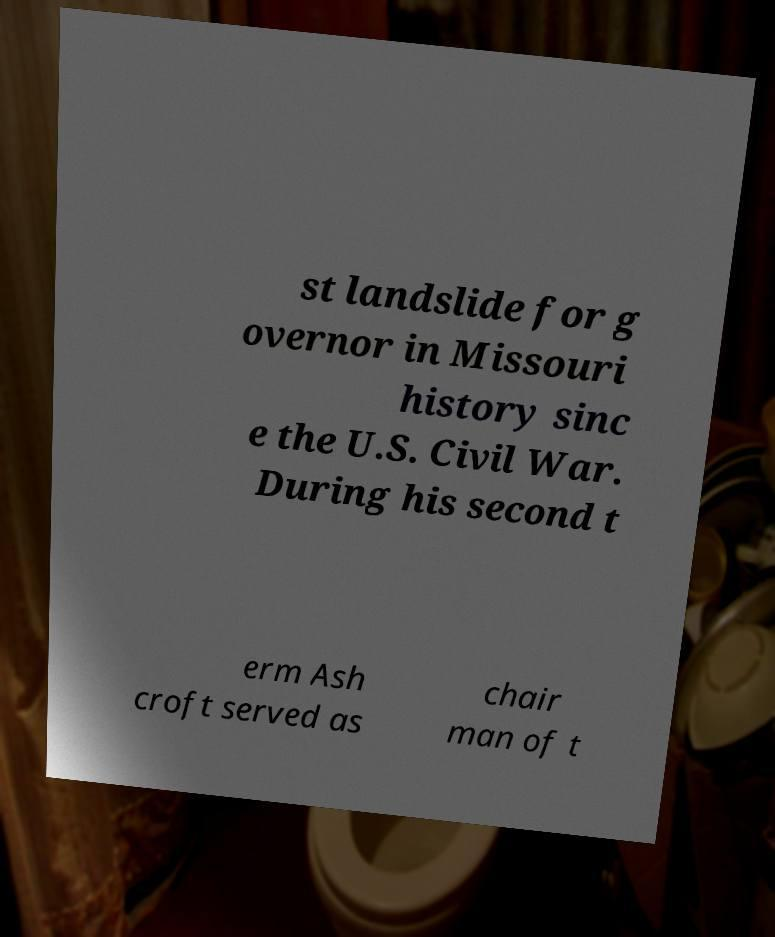Please read and relay the text visible in this image. What does it say? st landslide for g overnor in Missouri history sinc e the U.S. Civil War. During his second t erm Ash croft served as chair man of t 